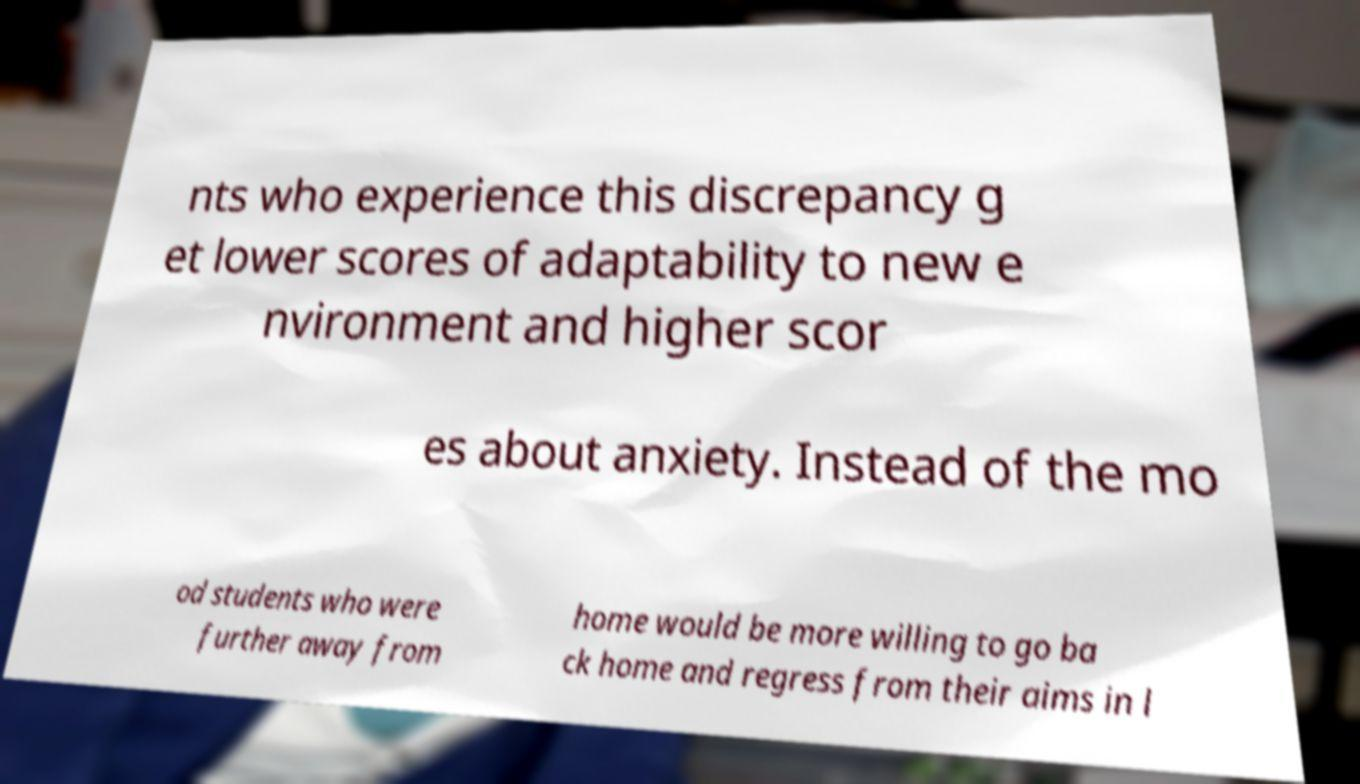There's text embedded in this image that I need extracted. Can you transcribe it verbatim? nts who experience this discrepancy g et lower scores of adaptability to new e nvironment and higher scor es about anxiety. Instead of the mo od students who were further away from home would be more willing to go ba ck home and regress from their aims in l 